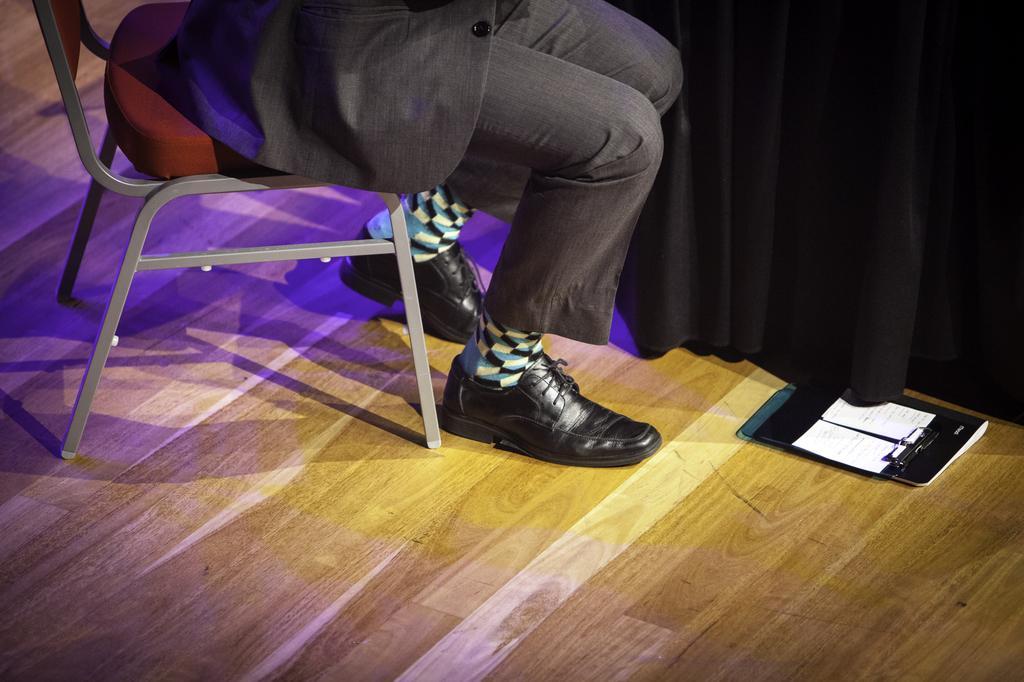In one or two sentences, can you explain what this image depicts? In this image, we can see a person sitting on the chair and in the background, we can see a curtain. At the bottom, there is a book on the floor. 